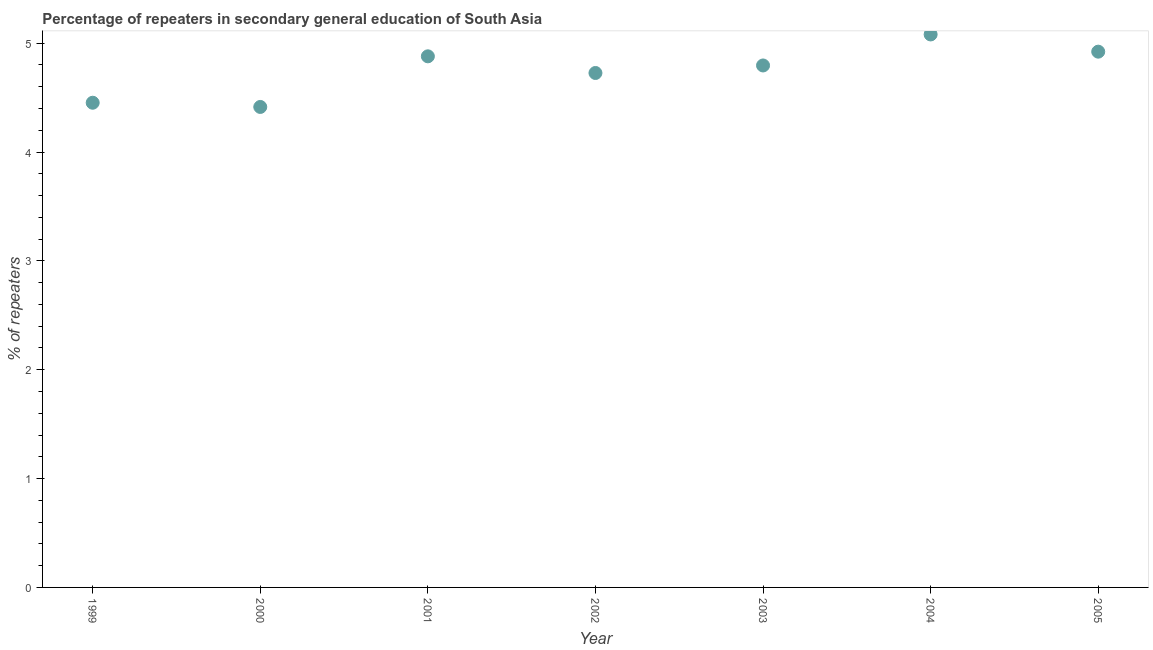What is the percentage of repeaters in 2005?
Provide a short and direct response. 4.92. Across all years, what is the maximum percentage of repeaters?
Ensure brevity in your answer.  5.08. Across all years, what is the minimum percentage of repeaters?
Your answer should be compact. 4.41. In which year was the percentage of repeaters minimum?
Your answer should be compact. 2000. What is the sum of the percentage of repeaters?
Your answer should be compact. 33.27. What is the difference between the percentage of repeaters in 2002 and 2005?
Keep it short and to the point. -0.2. What is the average percentage of repeaters per year?
Your answer should be very brief. 4.75. What is the median percentage of repeaters?
Keep it short and to the point. 4.8. In how many years, is the percentage of repeaters greater than 2 %?
Provide a short and direct response. 7. What is the ratio of the percentage of repeaters in 2000 to that in 2004?
Make the answer very short. 0.87. Is the difference between the percentage of repeaters in 2001 and 2005 greater than the difference between any two years?
Keep it short and to the point. No. What is the difference between the highest and the second highest percentage of repeaters?
Provide a succinct answer. 0.16. What is the difference between the highest and the lowest percentage of repeaters?
Keep it short and to the point. 0.67. In how many years, is the percentage of repeaters greater than the average percentage of repeaters taken over all years?
Your answer should be very brief. 4. How many dotlines are there?
Your answer should be very brief. 1. Does the graph contain any zero values?
Offer a terse response. No. What is the title of the graph?
Offer a terse response. Percentage of repeaters in secondary general education of South Asia. What is the label or title of the Y-axis?
Your answer should be very brief. % of repeaters. What is the % of repeaters in 1999?
Your response must be concise. 4.45. What is the % of repeaters in 2000?
Offer a terse response. 4.41. What is the % of repeaters in 2001?
Your response must be concise. 4.88. What is the % of repeaters in 2002?
Offer a terse response. 4.73. What is the % of repeaters in 2003?
Give a very brief answer. 4.8. What is the % of repeaters in 2004?
Offer a very short reply. 5.08. What is the % of repeaters in 2005?
Provide a short and direct response. 4.92. What is the difference between the % of repeaters in 1999 and 2000?
Give a very brief answer. 0.04. What is the difference between the % of repeaters in 1999 and 2001?
Provide a short and direct response. -0.43. What is the difference between the % of repeaters in 1999 and 2002?
Keep it short and to the point. -0.27. What is the difference between the % of repeaters in 1999 and 2003?
Provide a short and direct response. -0.34. What is the difference between the % of repeaters in 1999 and 2004?
Keep it short and to the point. -0.63. What is the difference between the % of repeaters in 1999 and 2005?
Offer a terse response. -0.47. What is the difference between the % of repeaters in 2000 and 2001?
Provide a succinct answer. -0.47. What is the difference between the % of repeaters in 2000 and 2002?
Your answer should be compact. -0.31. What is the difference between the % of repeaters in 2000 and 2003?
Provide a short and direct response. -0.38. What is the difference between the % of repeaters in 2000 and 2004?
Your answer should be compact. -0.67. What is the difference between the % of repeaters in 2000 and 2005?
Make the answer very short. -0.51. What is the difference between the % of repeaters in 2001 and 2002?
Ensure brevity in your answer.  0.15. What is the difference between the % of repeaters in 2001 and 2003?
Provide a succinct answer. 0.08. What is the difference between the % of repeaters in 2001 and 2004?
Your answer should be compact. -0.2. What is the difference between the % of repeaters in 2001 and 2005?
Provide a succinct answer. -0.04. What is the difference between the % of repeaters in 2002 and 2003?
Provide a short and direct response. -0.07. What is the difference between the % of repeaters in 2002 and 2004?
Keep it short and to the point. -0.35. What is the difference between the % of repeaters in 2002 and 2005?
Provide a short and direct response. -0.2. What is the difference between the % of repeaters in 2003 and 2004?
Your answer should be compact. -0.28. What is the difference between the % of repeaters in 2003 and 2005?
Your answer should be very brief. -0.13. What is the difference between the % of repeaters in 2004 and 2005?
Offer a terse response. 0.16. What is the ratio of the % of repeaters in 1999 to that in 2000?
Provide a succinct answer. 1.01. What is the ratio of the % of repeaters in 1999 to that in 2001?
Ensure brevity in your answer.  0.91. What is the ratio of the % of repeaters in 1999 to that in 2002?
Make the answer very short. 0.94. What is the ratio of the % of repeaters in 1999 to that in 2003?
Provide a succinct answer. 0.93. What is the ratio of the % of repeaters in 1999 to that in 2004?
Your response must be concise. 0.88. What is the ratio of the % of repeaters in 1999 to that in 2005?
Offer a very short reply. 0.91. What is the ratio of the % of repeaters in 2000 to that in 2001?
Provide a succinct answer. 0.91. What is the ratio of the % of repeaters in 2000 to that in 2002?
Ensure brevity in your answer.  0.93. What is the ratio of the % of repeaters in 2000 to that in 2003?
Make the answer very short. 0.92. What is the ratio of the % of repeaters in 2000 to that in 2004?
Your answer should be very brief. 0.87. What is the ratio of the % of repeaters in 2000 to that in 2005?
Your answer should be compact. 0.9. What is the ratio of the % of repeaters in 2001 to that in 2002?
Provide a succinct answer. 1.03. What is the ratio of the % of repeaters in 2001 to that in 2003?
Give a very brief answer. 1.02. What is the ratio of the % of repeaters in 2002 to that in 2004?
Your response must be concise. 0.93. What is the ratio of the % of repeaters in 2002 to that in 2005?
Give a very brief answer. 0.96. What is the ratio of the % of repeaters in 2003 to that in 2004?
Your answer should be very brief. 0.94. What is the ratio of the % of repeaters in 2004 to that in 2005?
Give a very brief answer. 1.03. 